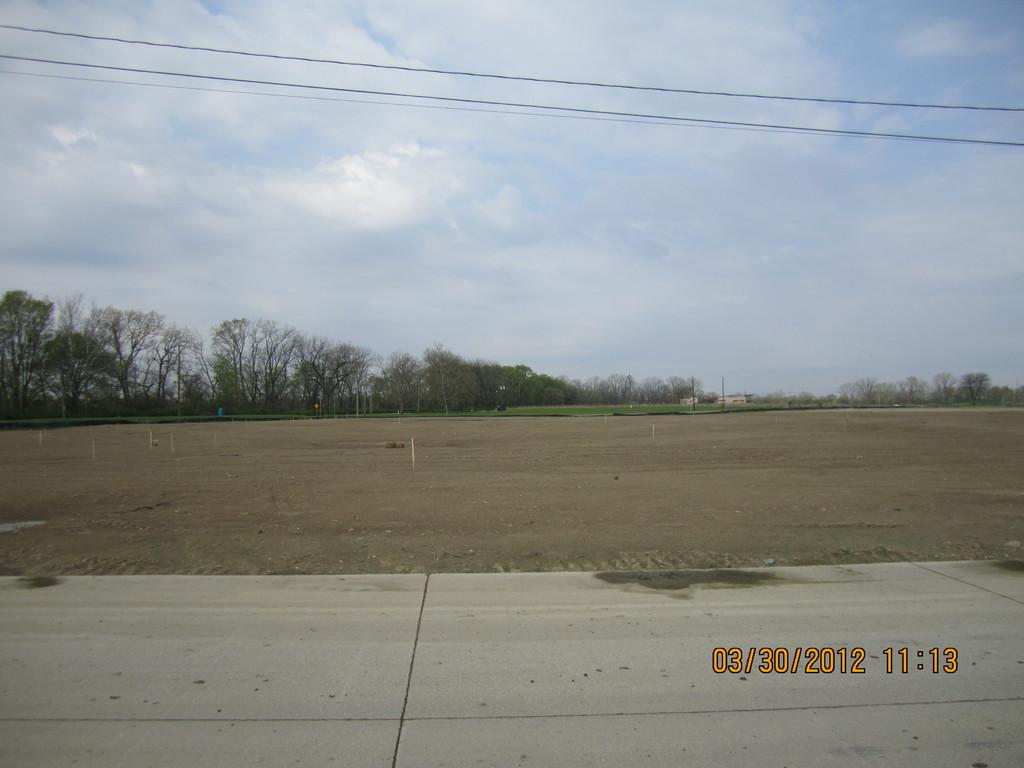What can be found in the bottom right of the image? There are numbers and symbols in the bottom right of the image. What type of natural environment is depicted in the image? There is grass and trees in the image, indicating a natural environment. What structures are present in the image? There are poles in the image. Can you describe any other objects in the image? There are other objects in the image, but their specific details are not mentioned in the provided facts. What else can be seen in the image? Wires are visible in the image. How would you describe the weather in the image? The sky is cloudy in the image, suggesting overcast or potentially rainy weather. What type of crime is being committed in the image? There is no indication of any crime being committed in the image. What color are the jeans worn by the person in the image? There is no person or jeans present in the image. 